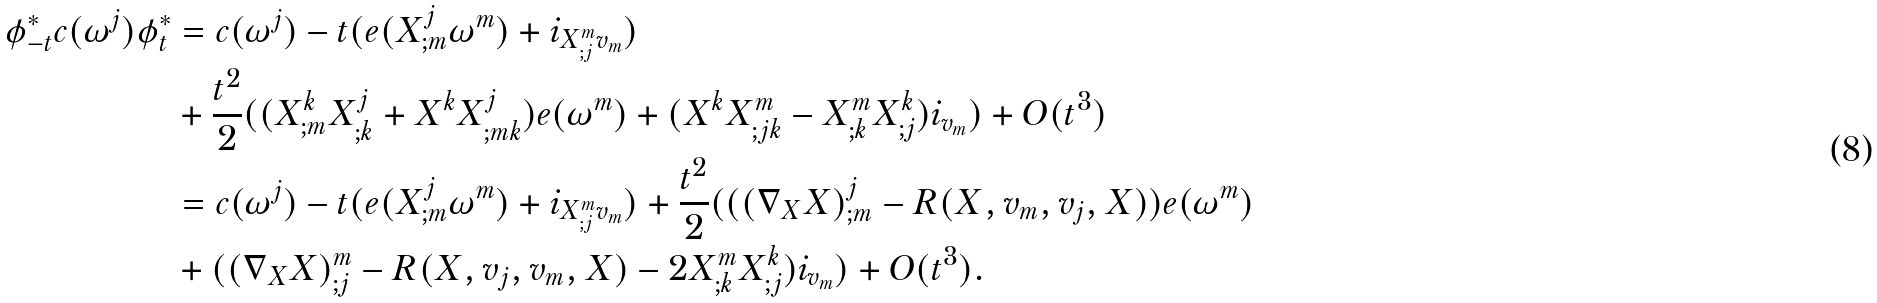<formula> <loc_0><loc_0><loc_500><loc_500>\phi _ { - t } ^ { * } c ( \omega ^ { j } ) \phi _ { t } ^ { * } & = c ( \omega ^ { j } ) - t ( e ( X ^ { j } _ { ; m } \omega ^ { m } ) + i _ { X ^ { m } _ { ; j } v _ { m } } ) \\ & + \frac { t ^ { 2 } } { 2 } ( ( X ^ { k } _ { ; m } X ^ { j } _ { ; k } + X ^ { k } X ^ { j } _ { ; m k } ) e ( \omega ^ { m } ) + ( X ^ { k } X ^ { m } _ { ; j k } - X ^ { m } _ { ; k } X ^ { k } _ { ; j } ) i _ { v _ { m } } ) + O ( t ^ { 3 } ) \\ & = c ( \omega ^ { j } ) - t ( e ( X ^ { j } _ { ; m } \omega ^ { m } ) + i _ { X ^ { m } _ { ; j } v _ { m } } ) + \frac { t ^ { 2 } } { 2 } ( ( ( \nabla _ { X } X ) ^ { j } _ { ; m } - R ( X , v _ { m } , v _ { j } , X ) ) e ( \omega ^ { m } ) \\ & + ( ( \nabla _ { X } X ) ^ { m } _ { ; j } - R ( X , v _ { j } , v _ { m } , X ) - 2 X ^ { m } _ { ; k } X ^ { k } _ { ; j } ) i _ { v _ { m } } ) + O ( t ^ { 3 } ) .</formula> 